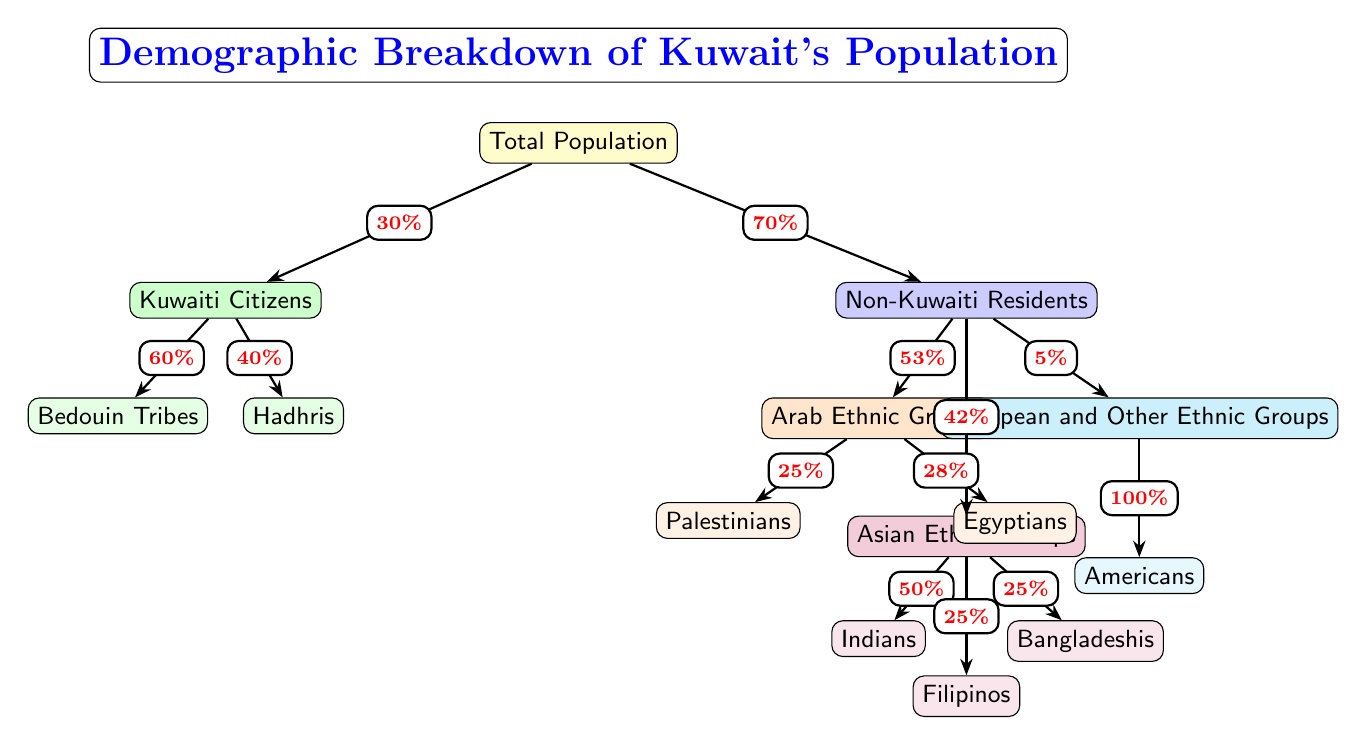What percentage of Kuwait's population are Kuwaiti citizens? The diagram shows a connection from the total population to the Kuwaiti citizens node, with an edge label indicating the percentage of Kuwaiti citizens, which is 30%.
Answer: 30% What ethnic groups fall under Non-Kuwaiti Residents? The diagram clearly segments the Non-Kuwaiti Residents into three groups: Arab Ethnic Groups, Asian Ethnic Groups, and European and Other Ethnic Groups. These groups are explicitly listed in their respective nodes.
Answer: Arab Ethnic Groups, Asian Ethnic Groups, European and Other Ethnic Groups How much of the Non-Kuwaiti population consists of Asian ethnic groups? The edge leading to the Asian ethnic groups from Non-Kuwaiti Residents shows that they comprise 42% of the non-Kuwaiti population, as indicated by the edge label.
Answer: 42% Which group has a higher representation among Non-Kuwaiti Residents, Arab or Asian? By comparing the edge labels, Arab ethnic groups represent 53% and Asian ethnic groups represent 42% of non-Kuwaitis. Since 53% is greater than 42%, Arab ethnic groups have higher representation.
Answer: Arab What percentage of the total population is comprised of Bedouin Tribes? To find this, we start from the total population of Kuwait and look at the percentage of Kuwaiti citizens (30%), then further down to the Kuwaiti citizens categorized as Bedouin Tribes, which is 60% of the Kuwaiti citizens. Therefore, we calculate 30% * 60% = 18%.
Answer: 18% How many distinct ethnic groups are listed in the diagram under Non-Kuwaiti Residents? The diagram identifies three distinct groups under Non-Kuwaiti Residents—Arab Ethnic Groups, Asian Ethnic Groups, and European and Other Ethnic Groups. Each of these groups has specific subgroups or ethnicities listed underneath.
Answer: 3 Which specific subgroup constitutes 50% of the Asian Ethnic Groups? Looking at the Asian Ethnic Groups, the edge connections reveal that Indians represent 50% of that group. This information is found directly beneath the Asian node in the diagram.
Answer: Indians What is the total percentage of Palestinians and Egyptians within the Arab Ethnic Groups? The edge label for Palestinians is 25% and for Egyptians is 28%. To find the total percentage of both groups within the Arab ethnic groups, we simply add these two percentages together: 25% + 28% = 53%.
Answer: 53% What fraction of Non-Kuwaiti Residents are classified as European? From the diagram, the edge leading to the European and Other Ethnic Groups shows that they account for 5% of the Non-Kuwaiti Residents, based on the edge label under this category.
Answer: 5% 